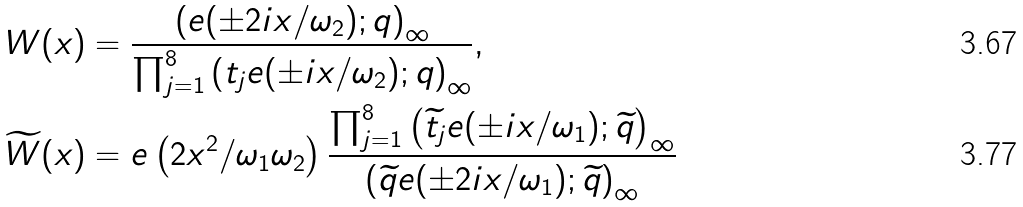Convert formula to latex. <formula><loc_0><loc_0><loc_500><loc_500>W ( x ) & = \frac { \left ( e ( \pm 2 i x / \omega _ { 2 } ) ; q \right ) _ { \infty } } { \prod _ { j = 1 } ^ { 8 } \left ( t _ { j } e ( \pm i x / \omega _ { 2 } ) ; q \right ) _ { \infty } } , \\ \widetilde { W } ( x ) & = e \left ( 2 x ^ { 2 } / \omega _ { 1 } \omega _ { 2 } \right ) \frac { \prod _ { j = 1 } ^ { 8 } \left ( \widetilde { t } _ { j } e ( \pm i x / \omega _ { 1 } ) ; \widetilde { q } \right ) _ { \infty } } { \left ( \widetilde { q } e ( \pm 2 i x / \omega _ { 1 } ) ; \widetilde { q } \right ) _ { \infty } }</formula> 